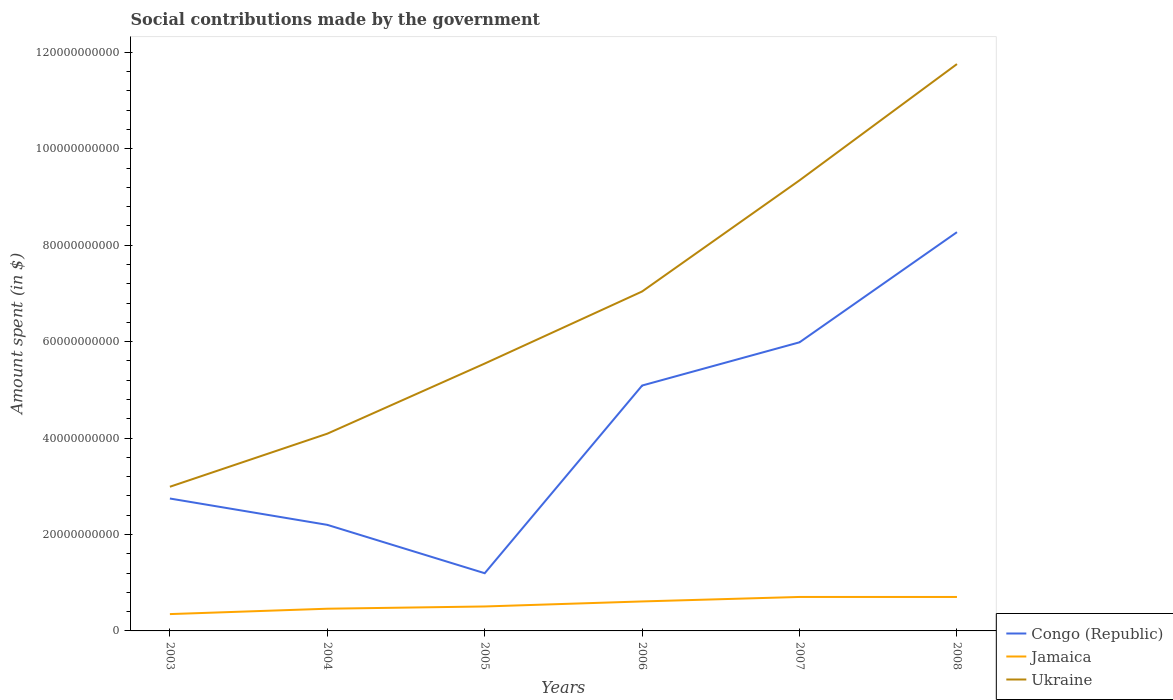Does the line corresponding to Jamaica intersect with the line corresponding to Congo (Republic)?
Your answer should be very brief. No. Across all years, what is the maximum amount spent on social contributions in Jamaica?
Offer a very short reply. 3.49e+09. What is the total amount spent on social contributions in Jamaica in the graph?
Ensure brevity in your answer.  -2.62e+09. What is the difference between the highest and the second highest amount spent on social contributions in Ukraine?
Offer a terse response. 8.77e+1. Is the amount spent on social contributions in Congo (Republic) strictly greater than the amount spent on social contributions in Ukraine over the years?
Your response must be concise. Yes. How many years are there in the graph?
Your answer should be compact. 6. Are the values on the major ticks of Y-axis written in scientific E-notation?
Offer a very short reply. No. Does the graph contain any zero values?
Ensure brevity in your answer.  No. Where does the legend appear in the graph?
Your response must be concise. Bottom right. What is the title of the graph?
Ensure brevity in your answer.  Social contributions made by the government. What is the label or title of the Y-axis?
Your answer should be very brief. Amount spent (in $). What is the Amount spent (in $) of Congo (Republic) in 2003?
Your response must be concise. 2.75e+1. What is the Amount spent (in $) of Jamaica in 2003?
Give a very brief answer. 3.49e+09. What is the Amount spent (in $) of Ukraine in 2003?
Offer a very short reply. 2.99e+1. What is the Amount spent (in $) in Congo (Republic) in 2004?
Offer a very short reply. 2.20e+1. What is the Amount spent (in $) of Jamaica in 2004?
Offer a terse response. 4.60e+09. What is the Amount spent (in $) in Ukraine in 2004?
Provide a succinct answer. 4.09e+1. What is the Amount spent (in $) in Congo (Republic) in 2005?
Give a very brief answer. 1.20e+1. What is the Amount spent (in $) in Jamaica in 2005?
Give a very brief answer. 5.07e+09. What is the Amount spent (in $) of Ukraine in 2005?
Provide a short and direct response. 5.55e+1. What is the Amount spent (in $) of Congo (Republic) in 2006?
Your answer should be compact. 5.09e+1. What is the Amount spent (in $) of Jamaica in 2006?
Keep it short and to the point. 6.12e+09. What is the Amount spent (in $) in Ukraine in 2006?
Your answer should be very brief. 7.04e+1. What is the Amount spent (in $) of Congo (Republic) in 2007?
Ensure brevity in your answer.  5.99e+1. What is the Amount spent (in $) of Jamaica in 2007?
Provide a short and direct response. 7.05e+09. What is the Amount spent (in $) of Ukraine in 2007?
Give a very brief answer. 9.35e+1. What is the Amount spent (in $) in Congo (Republic) in 2008?
Offer a terse response. 8.27e+1. What is the Amount spent (in $) in Jamaica in 2008?
Offer a very short reply. 7.04e+09. What is the Amount spent (in $) in Ukraine in 2008?
Offer a very short reply. 1.18e+11. Across all years, what is the maximum Amount spent (in $) of Congo (Republic)?
Your answer should be compact. 8.27e+1. Across all years, what is the maximum Amount spent (in $) in Jamaica?
Your answer should be compact. 7.05e+09. Across all years, what is the maximum Amount spent (in $) of Ukraine?
Give a very brief answer. 1.18e+11. Across all years, what is the minimum Amount spent (in $) of Congo (Republic)?
Make the answer very short. 1.20e+1. Across all years, what is the minimum Amount spent (in $) in Jamaica?
Provide a succinct answer. 3.49e+09. Across all years, what is the minimum Amount spent (in $) in Ukraine?
Make the answer very short. 2.99e+1. What is the total Amount spent (in $) of Congo (Republic) in the graph?
Offer a terse response. 2.55e+11. What is the total Amount spent (in $) of Jamaica in the graph?
Make the answer very short. 3.34e+1. What is the total Amount spent (in $) in Ukraine in the graph?
Your answer should be compact. 4.08e+11. What is the difference between the Amount spent (in $) in Congo (Republic) in 2003 and that in 2004?
Offer a very short reply. 5.46e+09. What is the difference between the Amount spent (in $) in Jamaica in 2003 and that in 2004?
Offer a very short reply. -1.11e+09. What is the difference between the Amount spent (in $) in Ukraine in 2003 and that in 2004?
Your answer should be very brief. -1.10e+1. What is the difference between the Amount spent (in $) of Congo (Republic) in 2003 and that in 2005?
Ensure brevity in your answer.  1.55e+1. What is the difference between the Amount spent (in $) of Jamaica in 2003 and that in 2005?
Give a very brief answer. -1.58e+09. What is the difference between the Amount spent (in $) of Ukraine in 2003 and that in 2005?
Your answer should be very brief. -2.56e+1. What is the difference between the Amount spent (in $) of Congo (Republic) in 2003 and that in 2006?
Make the answer very short. -2.34e+1. What is the difference between the Amount spent (in $) in Jamaica in 2003 and that in 2006?
Provide a succinct answer. -2.62e+09. What is the difference between the Amount spent (in $) in Ukraine in 2003 and that in 2006?
Offer a terse response. -4.05e+1. What is the difference between the Amount spent (in $) in Congo (Republic) in 2003 and that in 2007?
Give a very brief answer. -3.24e+1. What is the difference between the Amount spent (in $) in Jamaica in 2003 and that in 2007?
Your response must be concise. -3.55e+09. What is the difference between the Amount spent (in $) of Ukraine in 2003 and that in 2007?
Your response must be concise. -6.36e+1. What is the difference between the Amount spent (in $) of Congo (Republic) in 2003 and that in 2008?
Provide a short and direct response. -5.52e+1. What is the difference between the Amount spent (in $) of Jamaica in 2003 and that in 2008?
Your answer should be very brief. -3.55e+09. What is the difference between the Amount spent (in $) in Ukraine in 2003 and that in 2008?
Your answer should be very brief. -8.77e+1. What is the difference between the Amount spent (in $) in Congo (Republic) in 2004 and that in 2005?
Your answer should be very brief. 1.00e+1. What is the difference between the Amount spent (in $) in Jamaica in 2004 and that in 2005?
Make the answer very short. -4.69e+08. What is the difference between the Amount spent (in $) in Ukraine in 2004 and that in 2005?
Make the answer very short. -1.45e+1. What is the difference between the Amount spent (in $) in Congo (Republic) in 2004 and that in 2006?
Ensure brevity in your answer.  -2.89e+1. What is the difference between the Amount spent (in $) in Jamaica in 2004 and that in 2006?
Provide a succinct answer. -1.51e+09. What is the difference between the Amount spent (in $) of Ukraine in 2004 and that in 2006?
Your answer should be very brief. -2.95e+1. What is the difference between the Amount spent (in $) of Congo (Republic) in 2004 and that in 2007?
Make the answer very short. -3.79e+1. What is the difference between the Amount spent (in $) of Jamaica in 2004 and that in 2007?
Ensure brevity in your answer.  -2.44e+09. What is the difference between the Amount spent (in $) of Ukraine in 2004 and that in 2007?
Give a very brief answer. -5.26e+1. What is the difference between the Amount spent (in $) in Congo (Republic) in 2004 and that in 2008?
Ensure brevity in your answer.  -6.07e+1. What is the difference between the Amount spent (in $) of Jamaica in 2004 and that in 2008?
Keep it short and to the point. -2.44e+09. What is the difference between the Amount spent (in $) of Ukraine in 2004 and that in 2008?
Ensure brevity in your answer.  -7.67e+1. What is the difference between the Amount spent (in $) of Congo (Republic) in 2005 and that in 2006?
Make the answer very short. -3.89e+1. What is the difference between the Amount spent (in $) of Jamaica in 2005 and that in 2006?
Your answer should be compact. -1.04e+09. What is the difference between the Amount spent (in $) in Ukraine in 2005 and that in 2006?
Make the answer very short. -1.50e+1. What is the difference between the Amount spent (in $) in Congo (Republic) in 2005 and that in 2007?
Provide a short and direct response. -4.79e+1. What is the difference between the Amount spent (in $) of Jamaica in 2005 and that in 2007?
Offer a terse response. -1.97e+09. What is the difference between the Amount spent (in $) in Ukraine in 2005 and that in 2007?
Ensure brevity in your answer.  -3.80e+1. What is the difference between the Amount spent (in $) of Congo (Republic) in 2005 and that in 2008?
Provide a succinct answer. -7.07e+1. What is the difference between the Amount spent (in $) in Jamaica in 2005 and that in 2008?
Offer a very short reply. -1.97e+09. What is the difference between the Amount spent (in $) of Ukraine in 2005 and that in 2008?
Give a very brief answer. -6.21e+1. What is the difference between the Amount spent (in $) of Congo (Republic) in 2006 and that in 2007?
Your answer should be very brief. -8.97e+09. What is the difference between the Amount spent (in $) in Jamaica in 2006 and that in 2007?
Ensure brevity in your answer.  -9.30e+08. What is the difference between the Amount spent (in $) of Ukraine in 2006 and that in 2007?
Your response must be concise. -2.31e+1. What is the difference between the Amount spent (in $) in Congo (Republic) in 2006 and that in 2008?
Offer a very short reply. -3.18e+1. What is the difference between the Amount spent (in $) in Jamaica in 2006 and that in 2008?
Provide a succinct answer. -9.27e+08. What is the difference between the Amount spent (in $) of Ukraine in 2006 and that in 2008?
Your response must be concise. -4.72e+1. What is the difference between the Amount spent (in $) of Congo (Republic) in 2007 and that in 2008?
Your response must be concise. -2.28e+1. What is the difference between the Amount spent (in $) of Jamaica in 2007 and that in 2008?
Your response must be concise. 2.79e+06. What is the difference between the Amount spent (in $) in Ukraine in 2007 and that in 2008?
Provide a short and direct response. -2.41e+1. What is the difference between the Amount spent (in $) of Congo (Republic) in 2003 and the Amount spent (in $) of Jamaica in 2004?
Give a very brief answer. 2.29e+1. What is the difference between the Amount spent (in $) of Congo (Republic) in 2003 and the Amount spent (in $) of Ukraine in 2004?
Provide a short and direct response. -1.34e+1. What is the difference between the Amount spent (in $) in Jamaica in 2003 and the Amount spent (in $) in Ukraine in 2004?
Make the answer very short. -3.74e+1. What is the difference between the Amount spent (in $) in Congo (Republic) in 2003 and the Amount spent (in $) in Jamaica in 2005?
Give a very brief answer. 2.24e+1. What is the difference between the Amount spent (in $) in Congo (Republic) in 2003 and the Amount spent (in $) in Ukraine in 2005?
Make the answer very short. -2.80e+1. What is the difference between the Amount spent (in $) in Jamaica in 2003 and the Amount spent (in $) in Ukraine in 2005?
Offer a very short reply. -5.20e+1. What is the difference between the Amount spent (in $) of Congo (Republic) in 2003 and the Amount spent (in $) of Jamaica in 2006?
Give a very brief answer. 2.13e+1. What is the difference between the Amount spent (in $) of Congo (Republic) in 2003 and the Amount spent (in $) of Ukraine in 2006?
Provide a short and direct response. -4.29e+1. What is the difference between the Amount spent (in $) of Jamaica in 2003 and the Amount spent (in $) of Ukraine in 2006?
Keep it short and to the point. -6.69e+1. What is the difference between the Amount spent (in $) of Congo (Republic) in 2003 and the Amount spent (in $) of Jamaica in 2007?
Provide a succinct answer. 2.04e+1. What is the difference between the Amount spent (in $) in Congo (Republic) in 2003 and the Amount spent (in $) in Ukraine in 2007?
Offer a very short reply. -6.60e+1. What is the difference between the Amount spent (in $) of Jamaica in 2003 and the Amount spent (in $) of Ukraine in 2007?
Offer a very short reply. -9.00e+1. What is the difference between the Amount spent (in $) of Congo (Republic) in 2003 and the Amount spent (in $) of Jamaica in 2008?
Provide a succinct answer. 2.04e+1. What is the difference between the Amount spent (in $) in Congo (Republic) in 2003 and the Amount spent (in $) in Ukraine in 2008?
Offer a terse response. -9.01e+1. What is the difference between the Amount spent (in $) in Jamaica in 2003 and the Amount spent (in $) in Ukraine in 2008?
Your response must be concise. -1.14e+11. What is the difference between the Amount spent (in $) of Congo (Republic) in 2004 and the Amount spent (in $) of Jamaica in 2005?
Your response must be concise. 1.69e+1. What is the difference between the Amount spent (in $) of Congo (Republic) in 2004 and the Amount spent (in $) of Ukraine in 2005?
Make the answer very short. -3.35e+1. What is the difference between the Amount spent (in $) in Jamaica in 2004 and the Amount spent (in $) in Ukraine in 2005?
Keep it short and to the point. -5.09e+1. What is the difference between the Amount spent (in $) in Congo (Republic) in 2004 and the Amount spent (in $) in Jamaica in 2006?
Provide a short and direct response. 1.59e+1. What is the difference between the Amount spent (in $) of Congo (Republic) in 2004 and the Amount spent (in $) of Ukraine in 2006?
Offer a very short reply. -4.84e+1. What is the difference between the Amount spent (in $) of Jamaica in 2004 and the Amount spent (in $) of Ukraine in 2006?
Provide a succinct answer. -6.58e+1. What is the difference between the Amount spent (in $) in Congo (Republic) in 2004 and the Amount spent (in $) in Jamaica in 2007?
Offer a very short reply. 1.50e+1. What is the difference between the Amount spent (in $) of Congo (Republic) in 2004 and the Amount spent (in $) of Ukraine in 2007?
Provide a succinct answer. -7.15e+1. What is the difference between the Amount spent (in $) of Jamaica in 2004 and the Amount spent (in $) of Ukraine in 2007?
Your answer should be very brief. -8.89e+1. What is the difference between the Amount spent (in $) in Congo (Republic) in 2004 and the Amount spent (in $) in Jamaica in 2008?
Make the answer very short. 1.50e+1. What is the difference between the Amount spent (in $) in Congo (Republic) in 2004 and the Amount spent (in $) in Ukraine in 2008?
Keep it short and to the point. -9.56e+1. What is the difference between the Amount spent (in $) of Jamaica in 2004 and the Amount spent (in $) of Ukraine in 2008?
Provide a succinct answer. -1.13e+11. What is the difference between the Amount spent (in $) in Congo (Republic) in 2005 and the Amount spent (in $) in Jamaica in 2006?
Your answer should be very brief. 5.85e+09. What is the difference between the Amount spent (in $) in Congo (Republic) in 2005 and the Amount spent (in $) in Ukraine in 2006?
Ensure brevity in your answer.  -5.84e+1. What is the difference between the Amount spent (in $) in Jamaica in 2005 and the Amount spent (in $) in Ukraine in 2006?
Make the answer very short. -6.53e+1. What is the difference between the Amount spent (in $) in Congo (Republic) in 2005 and the Amount spent (in $) in Jamaica in 2007?
Provide a short and direct response. 4.92e+09. What is the difference between the Amount spent (in $) of Congo (Republic) in 2005 and the Amount spent (in $) of Ukraine in 2007?
Your answer should be compact. -8.15e+1. What is the difference between the Amount spent (in $) of Jamaica in 2005 and the Amount spent (in $) of Ukraine in 2007?
Offer a very short reply. -8.84e+1. What is the difference between the Amount spent (in $) of Congo (Republic) in 2005 and the Amount spent (in $) of Jamaica in 2008?
Your answer should be compact. 4.93e+09. What is the difference between the Amount spent (in $) of Congo (Republic) in 2005 and the Amount spent (in $) of Ukraine in 2008?
Your answer should be compact. -1.06e+11. What is the difference between the Amount spent (in $) of Jamaica in 2005 and the Amount spent (in $) of Ukraine in 2008?
Ensure brevity in your answer.  -1.13e+11. What is the difference between the Amount spent (in $) of Congo (Republic) in 2006 and the Amount spent (in $) of Jamaica in 2007?
Your response must be concise. 4.39e+1. What is the difference between the Amount spent (in $) in Congo (Republic) in 2006 and the Amount spent (in $) in Ukraine in 2007?
Provide a short and direct response. -4.26e+1. What is the difference between the Amount spent (in $) in Jamaica in 2006 and the Amount spent (in $) in Ukraine in 2007?
Provide a succinct answer. -8.74e+1. What is the difference between the Amount spent (in $) of Congo (Republic) in 2006 and the Amount spent (in $) of Jamaica in 2008?
Provide a short and direct response. 4.39e+1. What is the difference between the Amount spent (in $) of Congo (Republic) in 2006 and the Amount spent (in $) of Ukraine in 2008?
Your response must be concise. -6.67e+1. What is the difference between the Amount spent (in $) of Jamaica in 2006 and the Amount spent (in $) of Ukraine in 2008?
Provide a succinct answer. -1.11e+11. What is the difference between the Amount spent (in $) of Congo (Republic) in 2007 and the Amount spent (in $) of Jamaica in 2008?
Ensure brevity in your answer.  5.28e+1. What is the difference between the Amount spent (in $) in Congo (Republic) in 2007 and the Amount spent (in $) in Ukraine in 2008?
Your answer should be compact. -5.77e+1. What is the difference between the Amount spent (in $) of Jamaica in 2007 and the Amount spent (in $) of Ukraine in 2008?
Your response must be concise. -1.11e+11. What is the average Amount spent (in $) in Congo (Republic) per year?
Your response must be concise. 4.25e+1. What is the average Amount spent (in $) in Jamaica per year?
Give a very brief answer. 5.56e+09. What is the average Amount spent (in $) in Ukraine per year?
Provide a short and direct response. 6.80e+1. In the year 2003, what is the difference between the Amount spent (in $) of Congo (Republic) and Amount spent (in $) of Jamaica?
Provide a short and direct response. 2.40e+1. In the year 2003, what is the difference between the Amount spent (in $) in Congo (Republic) and Amount spent (in $) in Ukraine?
Offer a very short reply. -2.44e+09. In the year 2003, what is the difference between the Amount spent (in $) in Jamaica and Amount spent (in $) in Ukraine?
Your answer should be very brief. -2.64e+1. In the year 2004, what is the difference between the Amount spent (in $) of Congo (Republic) and Amount spent (in $) of Jamaica?
Ensure brevity in your answer.  1.74e+1. In the year 2004, what is the difference between the Amount spent (in $) in Congo (Republic) and Amount spent (in $) in Ukraine?
Give a very brief answer. -1.89e+1. In the year 2004, what is the difference between the Amount spent (in $) in Jamaica and Amount spent (in $) in Ukraine?
Your answer should be very brief. -3.63e+1. In the year 2005, what is the difference between the Amount spent (in $) of Congo (Republic) and Amount spent (in $) of Jamaica?
Provide a succinct answer. 6.90e+09. In the year 2005, what is the difference between the Amount spent (in $) in Congo (Republic) and Amount spent (in $) in Ukraine?
Make the answer very short. -4.35e+1. In the year 2005, what is the difference between the Amount spent (in $) of Jamaica and Amount spent (in $) of Ukraine?
Your response must be concise. -5.04e+1. In the year 2006, what is the difference between the Amount spent (in $) in Congo (Republic) and Amount spent (in $) in Jamaica?
Your answer should be very brief. 4.48e+1. In the year 2006, what is the difference between the Amount spent (in $) in Congo (Republic) and Amount spent (in $) in Ukraine?
Make the answer very short. -1.95e+1. In the year 2006, what is the difference between the Amount spent (in $) in Jamaica and Amount spent (in $) in Ukraine?
Your answer should be compact. -6.43e+1. In the year 2007, what is the difference between the Amount spent (in $) of Congo (Republic) and Amount spent (in $) of Jamaica?
Your answer should be compact. 5.28e+1. In the year 2007, what is the difference between the Amount spent (in $) in Congo (Republic) and Amount spent (in $) in Ukraine?
Keep it short and to the point. -3.36e+1. In the year 2007, what is the difference between the Amount spent (in $) in Jamaica and Amount spent (in $) in Ukraine?
Give a very brief answer. -8.64e+1. In the year 2008, what is the difference between the Amount spent (in $) of Congo (Republic) and Amount spent (in $) of Jamaica?
Offer a very short reply. 7.57e+1. In the year 2008, what is the difference between the Amount spent (in $) in Congo (Republic) and Amount spent (in $) in Ukraine?
Your answer should be compact. -3.49e+1. In the year 2008, what is the difference between the Amount spent (in $) of Jamaica and Amount spent (in $) of Ukraine?
Your response must be concise. -1.11e+11. What is the ratio of the Amount spent (in $) of Congo (Republic) in 2003 to that in 2004?
Make the answer very short. 1.25. What is the ratio of the Amount spent (in $) in Jamaica in 2003 to that in 2004?
Your answer should be very brief. 0.76. What is the ratio of the Amount spent (in $) of Ukraine in 2003 to that in 2004?
Give a very brief answer. 0.73. What is the ratio of the Amount spent (in $) of Congo (Republic) in 2003 to that in 2005?
Your answer should be very brief. 2.29. What is the ratio of the Amount spent (in $) of Jamaica in 2003 to that in 2005?
Make the answer very short. 0.69. What is the ratio of the Amount spent (in $) in Ukraine in 2003 to that in 2005?
Make the answer very short. 0.54. What is the ratio of the Amount spent (in $) of Congo (Republic) in 2003 to that in 2006?
Your answer should be very brief. 0.54. What is the ratio of the Amount spent (in $) of Jamaica in 2003 to that in 2006?
Your response must be concise. 0.57. What is the ratio of the Amount spent (in $) in Ukraine in 2003 to that in 2006?
Your answer should be compact. 0.42. What is the ratio of the Amount spent (in $) of Congo (Republic) in 2003 to that in 2007?
Ensure brevity in your answer.  0.46. What is the ratio of the Amount spent (in $) of Jamaica in 2003 to that in 2007?
Your response must be concise. 0.5. What is the ratio of the Amount spent (in $) in Ukraine in 2003 to that in 2007?
Ensure brevity in your answer.  0.32. What is the ratio of the Amount spent (in $) of Congo (Republic) in 2003 to that in 2008?
Provide a short and direct response. 0.33. What is the ratio of the Amount spent (in $) of Jamaica in 2003 to that in 2008?
Offer a very short reply. 0.5. What is the ratio of the Amount spent (in $) in Ukraine in 2003 to that in 2008?
Keep it short and to the point. 0.25. What is the ratio of the Amount spent (in $) of Congo (Republic) in 2004 to that in 2005?
Your response must be concise. 1.84. What is the ratio of the Amount spent (in $) in Jamaica in 2004 to that in 2005?
Offer a terse response. 0.91. What is the ratio of the Amount spent (in $) of Ukraine in 2004 to that in 2005?
Keep it short and to the point. 0.74. What is the ratio of the Amount spent (in $) of Congo (Republic) in 2004 to that in 2006?
Provide a succinct answer. 0.43. What is the ratio of the Amount spent (in $) in Jamaica in 2004 to that in 2006?
Your answer should be very brief. 0.75. What is the ratio of the Amount spent (in $) of Ukraine in 2004 to that in 2006?
Your answer should be very brief. 0.58. What is the ratio of the Amount spent (in $) in Congo (Republic) in 2004 to that in 2007?
Offer a terse response. 0.37. What is the ratio of the Amount spent (in $) of Jamaica in 2004 to that in 2007?
Your answer should be compact. 0.65. What is the ratio of the Amount spent (in $) in Ukraine in 2004 to that in 2007?
Your answer should be very brief. 0.44. What is the ratio of the Amount spent (in $) in Congo (Republic) in 2004 to that in 2008?
Make the answer very short. 0.27. What is the ratio of the Amount spent (in $) of Jamaica in 2004 to that in 2008?
Ensure brevity in your answer.  0.65. What is the ratio of the Amount spent (in $) in Ukraine in 2004 to that in 2008?
Give a very brief answer. 0.35. What is the ratio of the Amount spent (in $) in Congo (Republic) in 2005 to that in 2006?
Ensure brevity in your answer.  0.24. What is the ratio of the Amount spent (in $) of Jamaica in 2005 to that in 2006?
Your response must be concise. 0.83. What is the ratio of the Amount spent (in $) of Ukraine in 2005 to that in 2006?
Give a very brief answer. 0.79. What is the ratio of the Amount spent (in $) in Congo (Republic) in 2005 to that in 2007?
Your answer should be compact. 0.2. What is the ratio of the Amount spent (in $) of Jamaica in 2005 to that in 2007?
Provide a short and direct response. 0.72. What is the ratio of the Amount spent (in $) of Ukraine in 2005 to that in 2007?
Offer a terse response. 0.59. What is the ratio of the Amount spent (in $) in Congo (Republic) in 2005 to that in 2008?
Ensure brevity in your answer.  0.14. What is the ratio of the Amount spent (in $) in Jamaica in 2005 to that in 2008?
Keep it short and to the point. 0.72. What is the ratio of the Amount spent (in $) of Ukraine in 2005 to that in 2008?
Make the answer very short. 0.47. What is the ratio of the Amount spent (in $) in Congo (Republic) in 2006 to that in 2007?
Your response must be concise. 0.85. What is the ratio of the Amount spent (in $) in Jamaica in 2006 to that in 2007?
Offer a terse response. 0.87. What is the ratio of the Amount spent (in $) of Ukraine in 2006 to that in 2007?
Offer a terse response. 0.75. What is the ratio of the Amount spent (in $) of Congo (Republic) in 2006 to that in 2008?
Provide a succinct answer. 0.62. What is the ratio of the Amount spent (in $) of Jamaica in 2006 to that in 2008?
Offer a very short reply. 0.87. What is the ratio of the Amount spent (in $) in Ukraine in 2006 to that in 2008?
Keep it short and to the point. 0.6. What is the ratio of the Amount spent (in $) in Congo (Republic) in 2007 to that in 2008?
Offer a very short reply. 0.72. What is the ratio of the Amount spent (in $) in Jamaica in 2007 to that in 2008?
Your answer should be compact. 1. What is the ratio of the Amount spent (in $) of Ukraine in 2007 to that in 2008?
Provide a succinct answer. 0.79. What is the difference between the highest and the second highest Amount spent (in $) of Congo (Republic)?
Provide a short and direct response. 2.28e+1. What is the difference between the highest and the second highest Amount spent (in $) in Jamaica?
Your response must be concise. 2.79e+06. What is the difference between the highest and the second highest Amount spent (in $) of Ukraine?
Offer a very short reply. 2.41e+1. What is the difference between the highest and the lowest Amount spent (in $) of Congo (Republic)?
Ensure brevity in your answer.  7.07e+1. What is the difference between the highest and the lowest Amount spent (in $) of Jamaica?
Your answer should be compact. 3.55e+09. What is the difference between the highest and the lowest Amount spent (in $) in Ukraine?
Keep it short and to the point. 8.77e+1. 